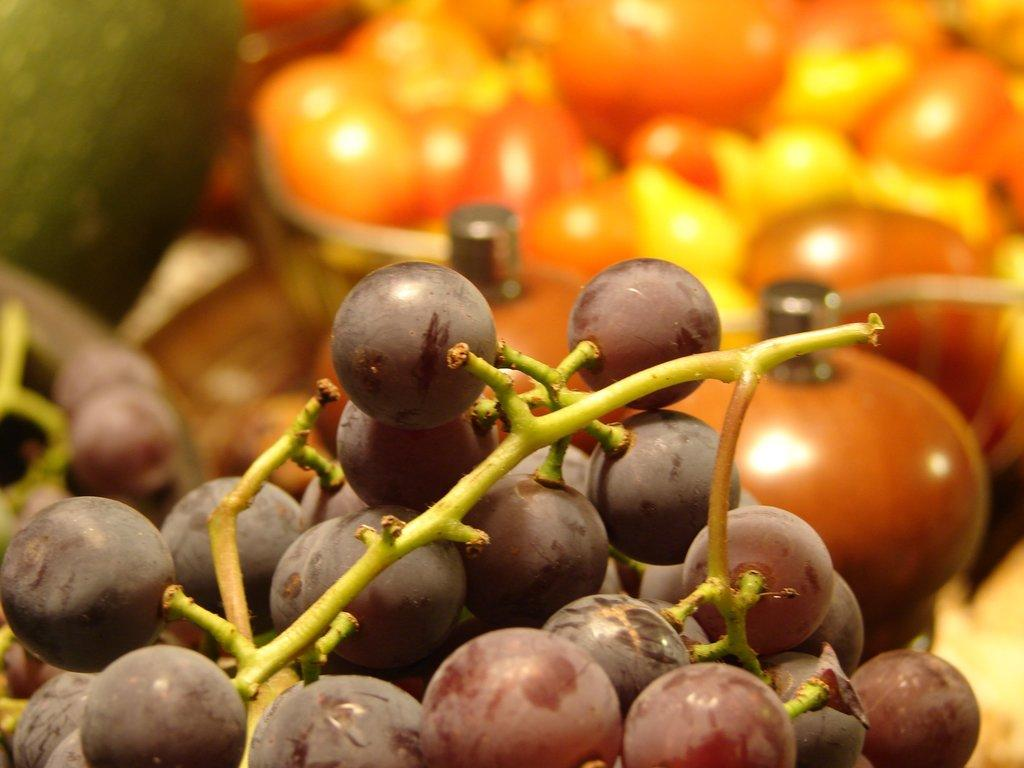What type of fruit is at the bottom of the image? There are black grapes at the bottom of the image. What other fruits can be seen in the image? The image contains fruits, but the specific types cannot be determined from the provided facts. Can you describe the background of the image? The background of the image is blurred. What type of quartz is being used to attack the fruits in the image? There is no quartz or attack present in the image. The image only contains black grapes and other fruits, with a blurred background. 